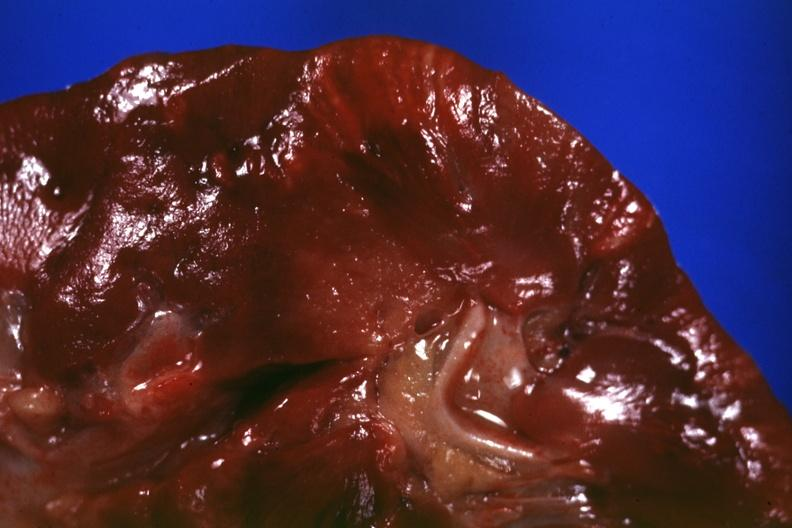what is present?
Answer the question using a single word or phrase. Kidney 